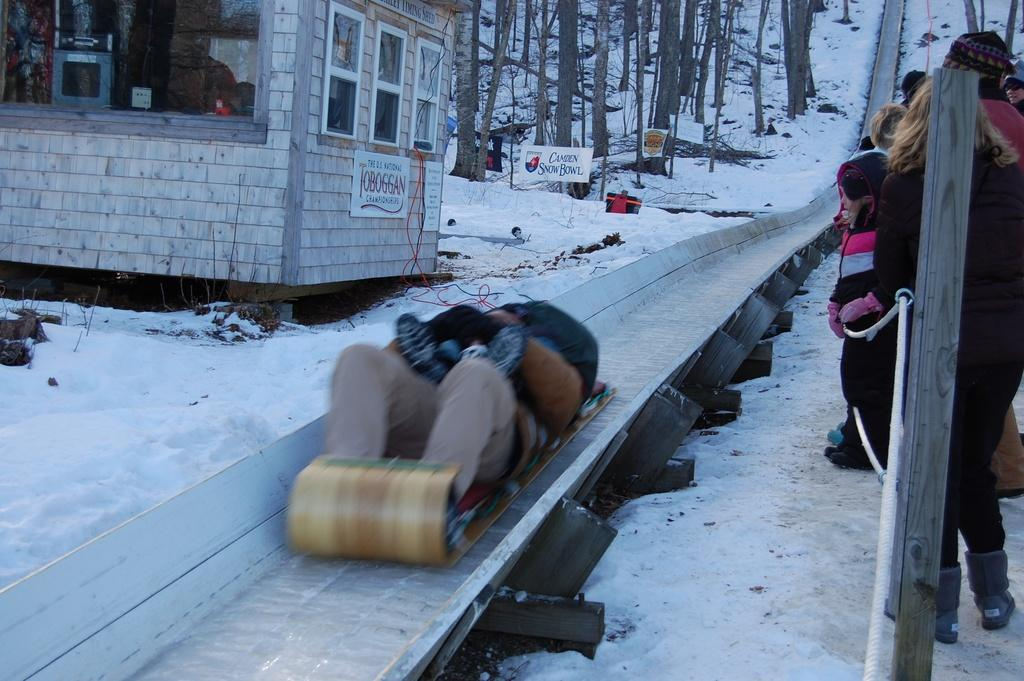What is the setting of the image? The background of the image is filled with snow. What are the people in the image doing? There are people standing in a group in the image, and one person is sliding. What are the other people in the group doing? The people in the group are watching the sliding person. What type of skirt is the stone wearing in the image? There is no stone or skirt present in the image. 